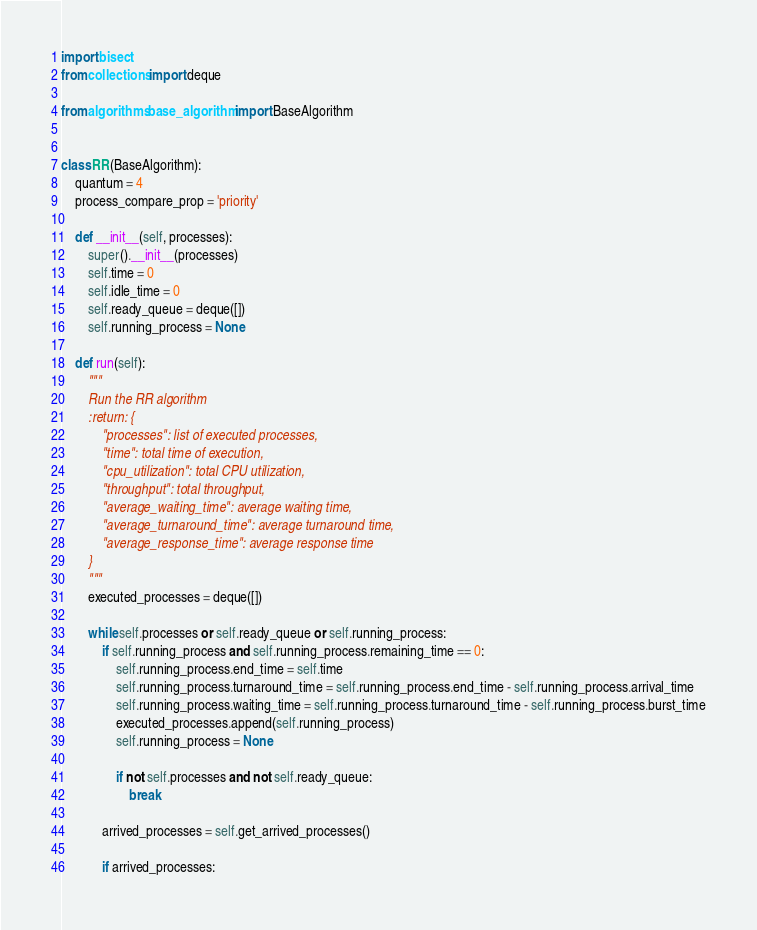Convert code to text. <code><loc_0><loc_0><loc_500><loc_500><_Python_>import bisect
from collections import deque

from algorithms.base_algorithm import BaseAlgorithm


class RR(BaseAlgorithm):
    quantum = 4
    process_compare_prop = 'priority'

    def __init__(self, processes):
        super().__init__(processes)
        self.time = 0
        self.idle_time = 0
        self.ready_queue = deque([])
        self.running_process = None

    def run(self):
        """
        Run the RR algorithm
        :return: {
            "processes": list of executed processes,
            "time": total time of execution,
            "cpu_utilization": total CPU utilization,
            "throughput": total throughput,
            "average_waiting_time": average waiting time,
            "average_turnaround_time": average turnaround time,
            "average_response_time": average response time
        }
        """
        executed_processes = deque([])

        while self.processes or self.ready_queue or self.running_process:
            if self.running_process and self.running_process.remaining_time == 0:
                self.running_process.end_time = self.time
                self.running_process.turnaround_time = self.running_process.end_time - self.running_process.arrival_time
                self.running_process.waiting_time = self.running_process.turnaround_time - self.running_process.burst_time
                executed_processes.append(self.running_process)
                self.running_process = None

                if not self.processes and not self.ready_queue:
                    break

            arrived_processes = self.get_arrived_processes()

            if arrived_processes:</code> 